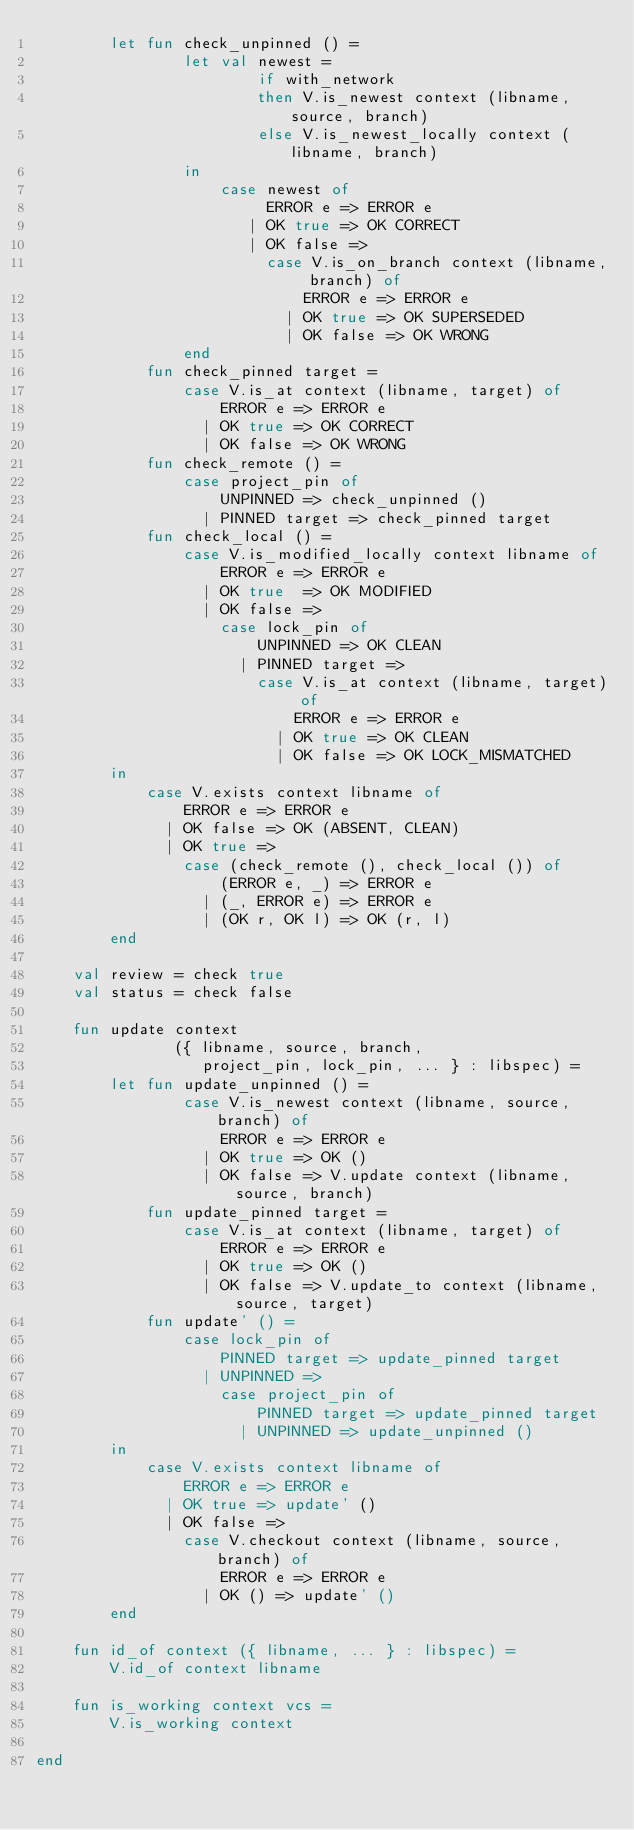<code> <loc_0><loc_0><loc_500><loc_500><_SML_>        let fun check_unpinned () =
                let val newest =
                        if with_network
                        then V.is_newest context (libname, source, branch)
                        else V.is_newest_locally context (libname, branch)
                in
                    case newest of
                         ERROR e => ERROR e
                       | OK true => OK CORRECT
                       | OK false =>
                         case V.is_on_branch context (libname, branch) of
                             ERROR e => ERROR e
                           | OK true => OK SUPERSEDED
                           | OK false => OK WRONG
                end
            fun check_pinned target =
                case V.is_at context (libname, target) of
                    ERROR e => ERROR e
                  | OK true => OK CORRECT
                  | OK false => OK WRONG
            fun check_remote () =
                case project_pin of
                    UNPINNED => check_unpinned ()
                  | PINNED target => check_pinned target
            fun check_local () =
                case V.is_modified_locally context libname of
                    ERROR e => ERROR e
                  | OK true  => OK MODIFIED
                  | OK false => 
                    case lock_pin of
                        UNPINNED => OK CLEAN
                      | PINNED target =>
                        case V.is_at context (libname, target) of
                            ERROR e => ERROR e
                          | OK true => OK CLEAN
                          | OK false => OK LOCK_MISMATCHED
        in
            case V.exists context libname of
                ERROR e => ERROR e
              | OK false => OK (ABSENT, CLEAN)
              | OK true =>
                case (check_remote (), check_local ()) of
                    (ERROR e, _) => ERROR e
                  | (_, ERROR e) => ERROR e
                  | (OK r, OK l) => OK (r, l)
        end

    val review = check true
    val status = check false

    fun update context
               ({ libname, source, branch,
                  project_pin, lock_pin, ... } : libspec) =
        let fun update_unpinned () =
                case V.is_newest context (libname, source, branch) of
                    ERROR e => ERROR e
                  | OK true => OK ()
                  | OK false => V.update context (libname, source, branch)
            fun update_pinned target =
                case V.is_at context (libname, target) of
                    ERROR e => ERROR e
                  | OK true => OK ()
                  | OK false => V.update_to context (libname, source, target)
            fun update' () =
                case lock_pin of
                    PINNED target => update_pinned target
                  | UNPINNED =>
                    case project_pin of
                        PINNED target => update_pinned target
                      | UNPINNED => update_unpinned ()
        in
            case V.exists context libname of
                ERROR e => ERROR e
              | OK true => update' ()
              | OK false =>
                case V.checkout context (libname, source, branch) of
                    ERROR e => ERROR e
                  | OK () => update' ()
        end

    fun id_of context ({ libname, ... } : libspec) =
        V.id_of context libname

    fun is_working context vcs =
        V.is_working context
                
end
</code> 